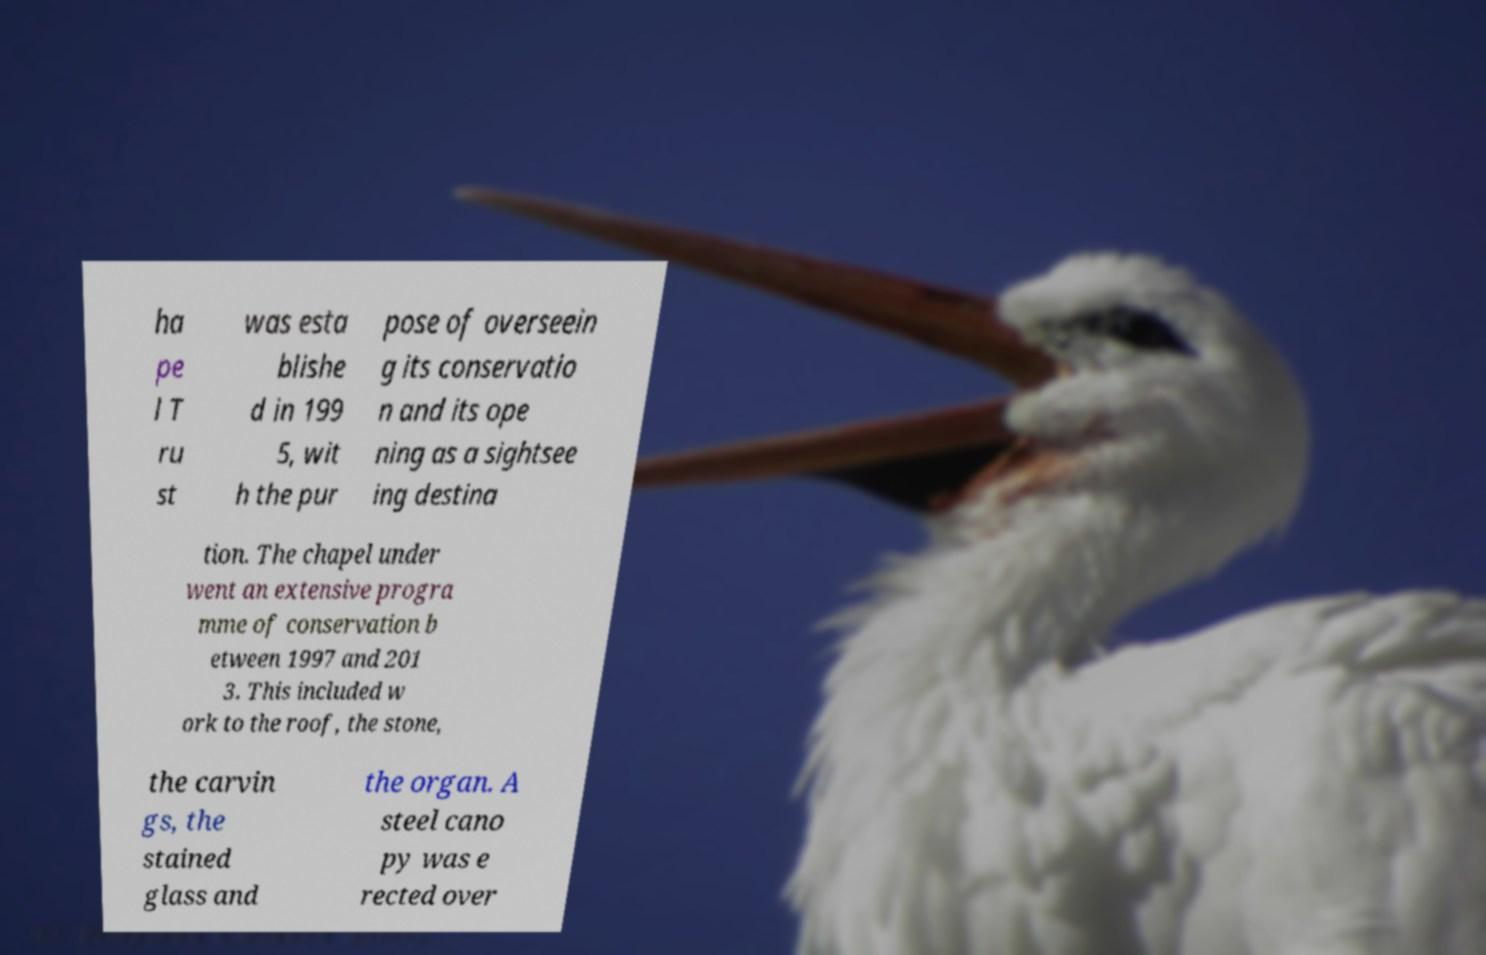Please read and relay the text visible in this image. What does it say? ha pe l T ru st was esta blishe d in 199 5, wit h the pur pose of overseein g its conservatio n and its ope ning as a sightsee ing destina tion. The chapel under went an extensive progra mme of conservation b etween 1997 and 201 3. This included w ork to the roof, the stone, the carvin gs, the stained glass and the organ. A steel cano py was e rected over 